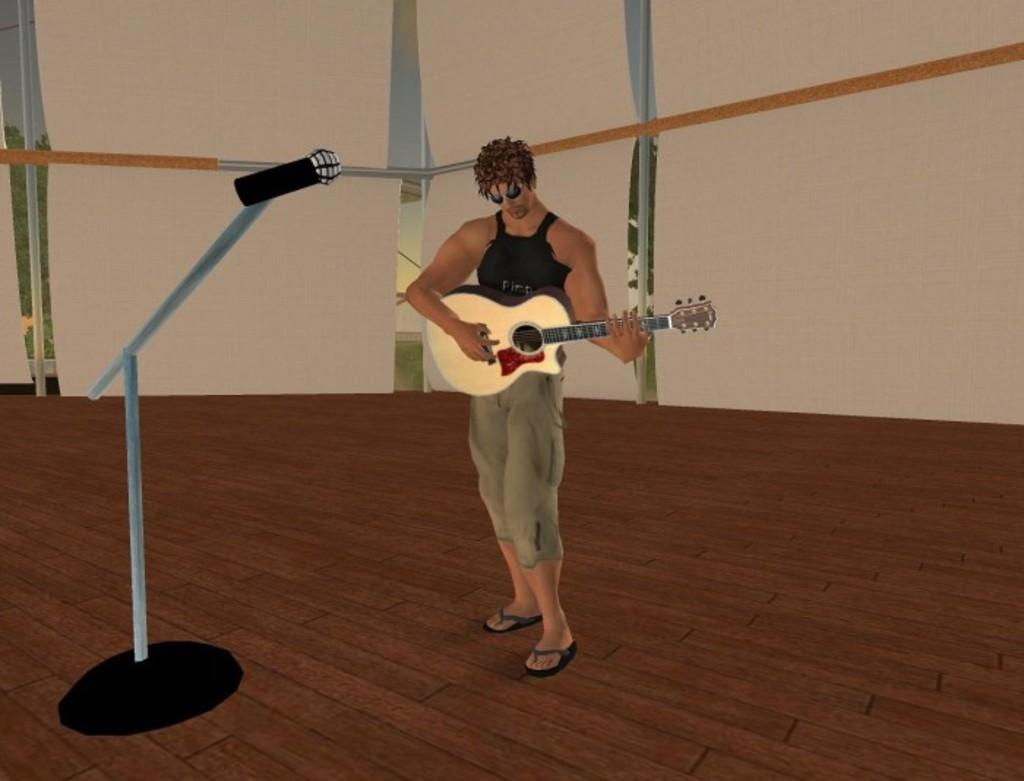What style is the image presented in? The image is a cartoon. What is the man in the image doing? The man is standing and playing a guitar. What object is in front of the man? There is a microphone with a microphone with a stand in front of the man. What type of chicken is playing the horn in the image? There is no chicken or horn present in the image. 